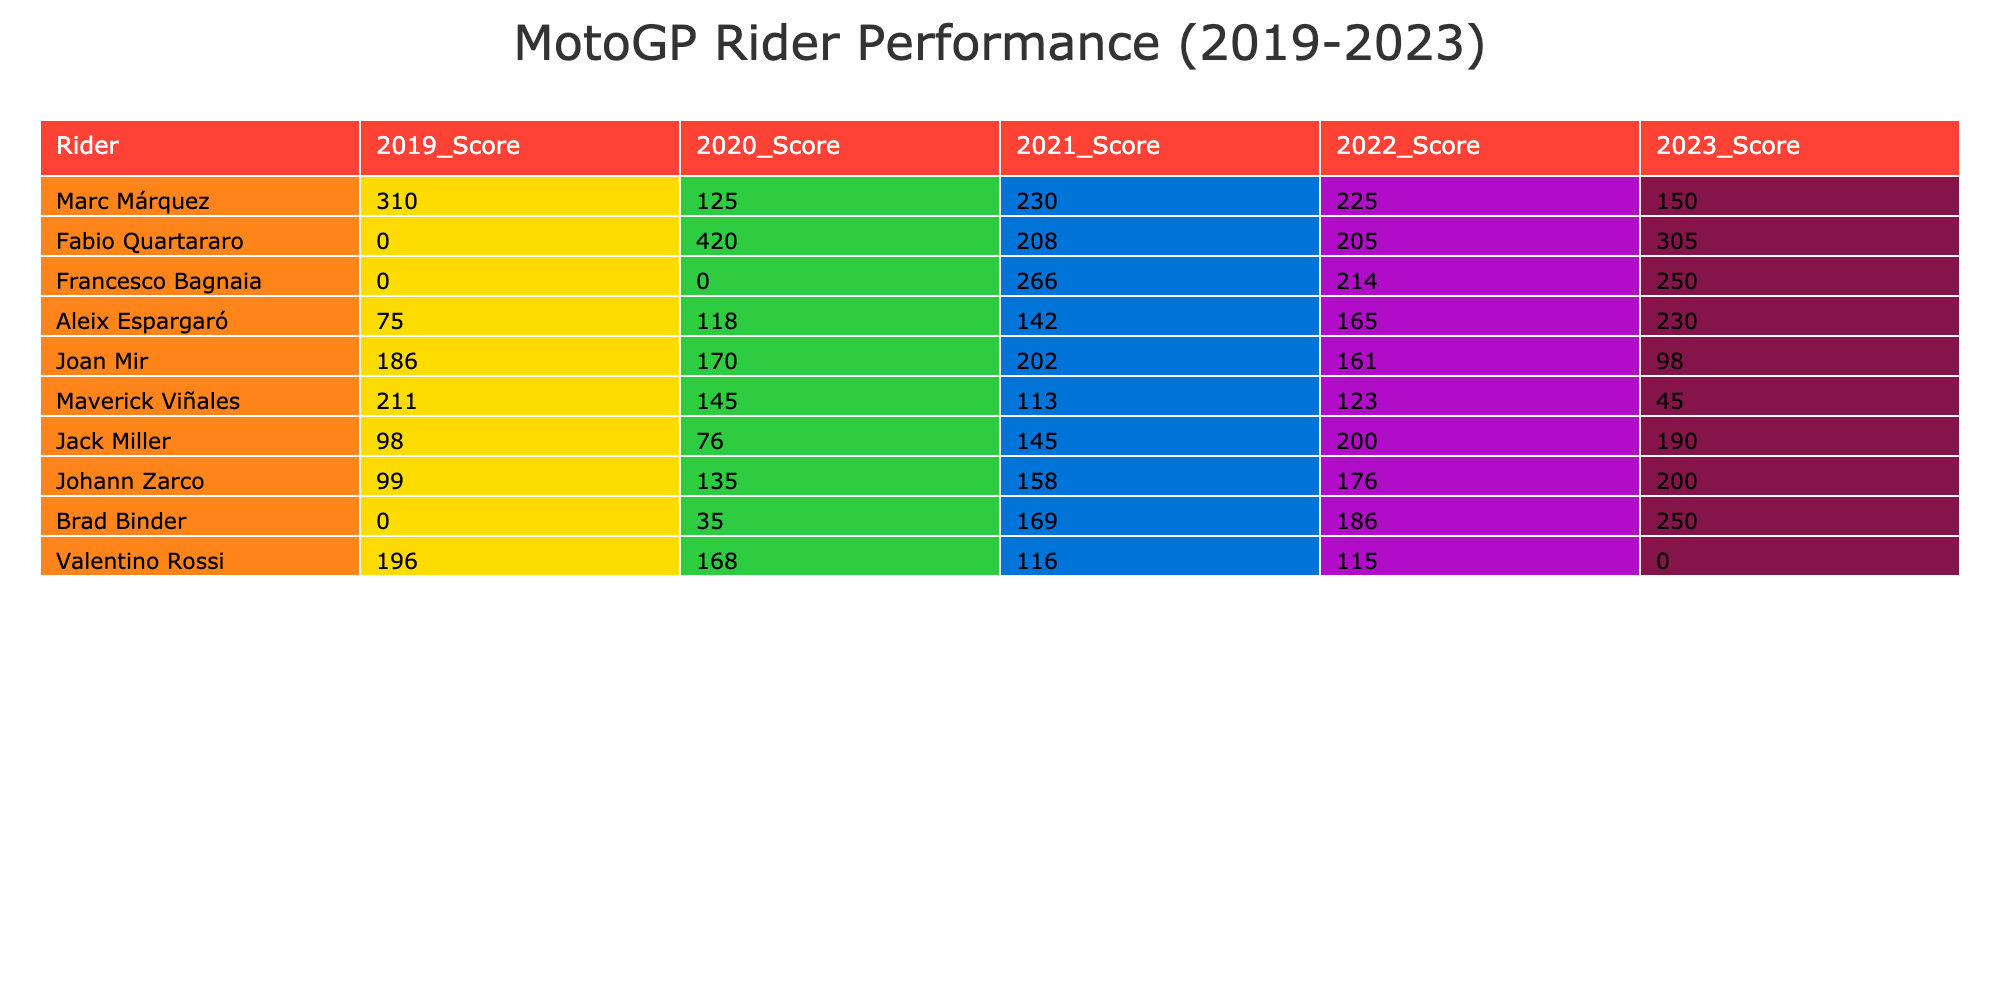What was Fabio Quartararo's score in 2020? According to the table, Fabio Quartararo's score in 2020 is given as 420.
Answer: 420 Who had the highest score in 2019? By reviewing the scores for 2019, Marc Márquez scored 310, which is higher than any other rider's score that year.
Answer: Marc Márquez What is the average score of Aleix Espargaró over the years listed? Aleix Espargaró's scores from 2019 to 2023 are 75, 118, 142, 165, and 230. To find the average: (75 + 118 + 142 + 165 + 230) / 5 = 166.
Answer: 166 Did Valentino Rossi score in 2023? Checking Valentino Rossi's score for 2023 in the table, it shows 0, which means he did not score any points that year.
Answer: No Which rider had a consistent performance from 2020 to 2023 with increasing scores? Analyzing the scores from 2020 to 2023, we see that Fabio Quartararo's scores are 420, 208, 205, and 305, which does not show consistent increases. However, Aleix Espargaró had scores of 118, 142, 165, and then increased to 230 in 2023, indicating a consistent upward trend.
Answer: Aleix Espargaró What was the difference in scores between Joan Mir and Johann Zarco in 2021? Joan Mir scored 202 and Johann Zarco scored 158 in 2021. The difference is calculated as 202 - 158 = 44.
Answer: 44 In 2022, which rider scored more than 200 points? Looking through the 2022 scores, only Marc Márquez (225), Francesco Bagnaia (214), Aleix Espargaró (165), Johann Zarco (176), and Jack Miller (200) scored over 200 points, but only Marc Márquez and Francesco Bagnaia did.
Answer: Marc Márquez and Francesco Bagnaia Which rider showed the most improvement in scores from 2020 to 2023? To determine improvement, we compare each rider's scores in 2020 and 2023. Fabio Quartararo went from 420 to 305, a decrease of 115. Aleix Espargaró went from 118 to 230, an increase of 112, which is the largest increase.
Answer: Aleix Espargaró 